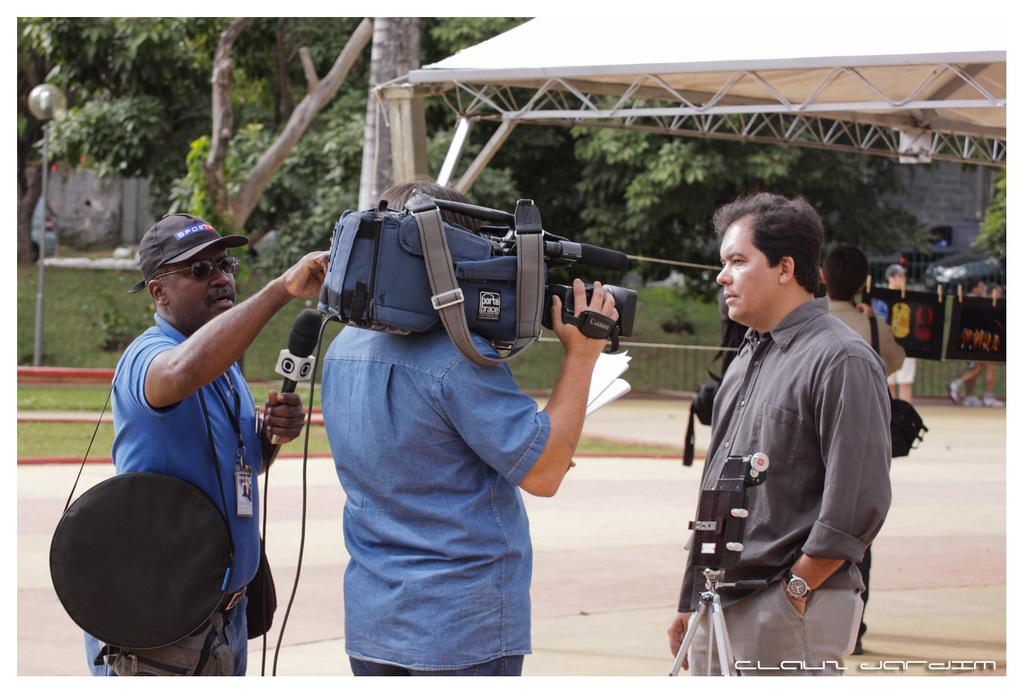How many people are visible in the image? There are people in the image, but the exact number is not specified. What are the people holding in the image? One person is holding a microphone, and another person is holding a camera. What can be seen in the background of the image? There are trees and additional people in the background of the image. What type of apple is being crushed by the person holding the microphone in the image? There is no apple or any crushing activity present in the image. 